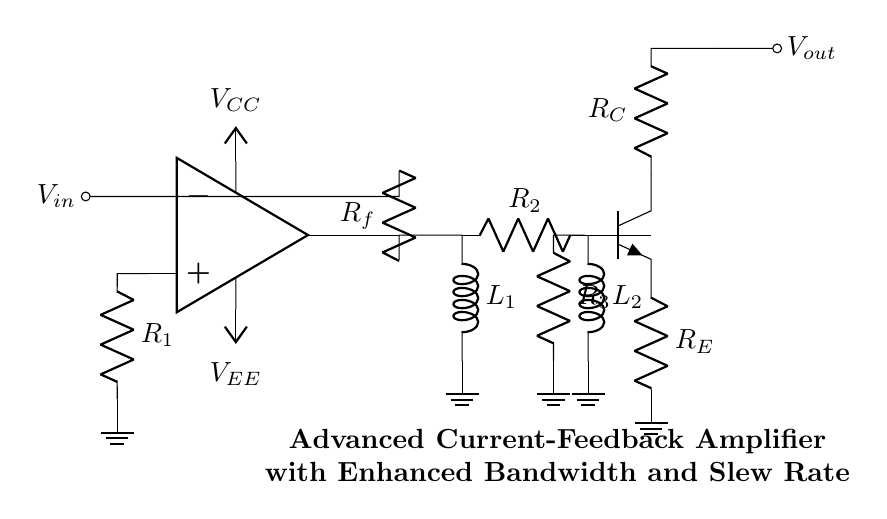What type of amplifier is shown in the circuit? The circuit diagram illustrates an advanced current-feedback amplifier, which is indicated by the title within the circuit and the components commonly used in such configurations.
Answer: current-feedback amplifier What are the values of the resistors in the feedback network? The circuit contains two resistors in the feedback path labeled as Rf and R1, which are typically part of the feedback network for determining the gain and stability of the amplifier.
Answer: R1 and Rf Which component enhances the slew rate? The component responsible for enhancing the slew rate in this amplifier is a transistor (npn) connected to resistors R3 and RE, indicating that it is part of the additional stage designed for improved performance.
Answer: transistor (npn) What is connected to the output node of the amplifier? The output node of the amplifier is connected to a terminal labeled Vout, where the amplified signal is expected to be taken for further processing or use.
Answer: Vout How many inductors are present in the circuit? The circuit includes two inductors labeled as L1 and L2 situated in the current mirror section, which are used for improving performance characteristics such as bandwidth.
Answer: two What is the purpose of the current mirror in this circuit? The current mirror, represented by the inductors L1 and L2, serves to ensure a constant current supply to the load, providing better linearity and higher bandwidth in the amplifier’s operation.
Answer: ensure constant current Which power supply voltages are indicated in the circuit? The circuit includes two power supply voltages labeled as Vcc and Vee, which are critical for providing power to the operational amplifier and ensuring it functions correctly within the specified range.
Answer: Vcc and Vee 